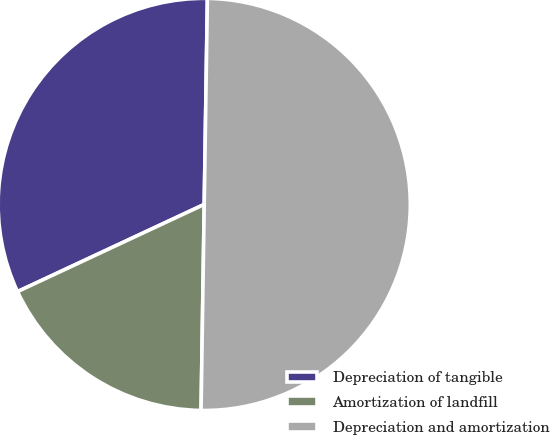<chart> <loc_0><loc_0><loc_500><loc_500><pie_chart><fcel>Depreciation of tangible<fcel>Amortization of landfill<fcel>Depreciation and amortization<nl><fcel>32.2%<fcel>17.8%<fcel>50.0%<nl></chart> 